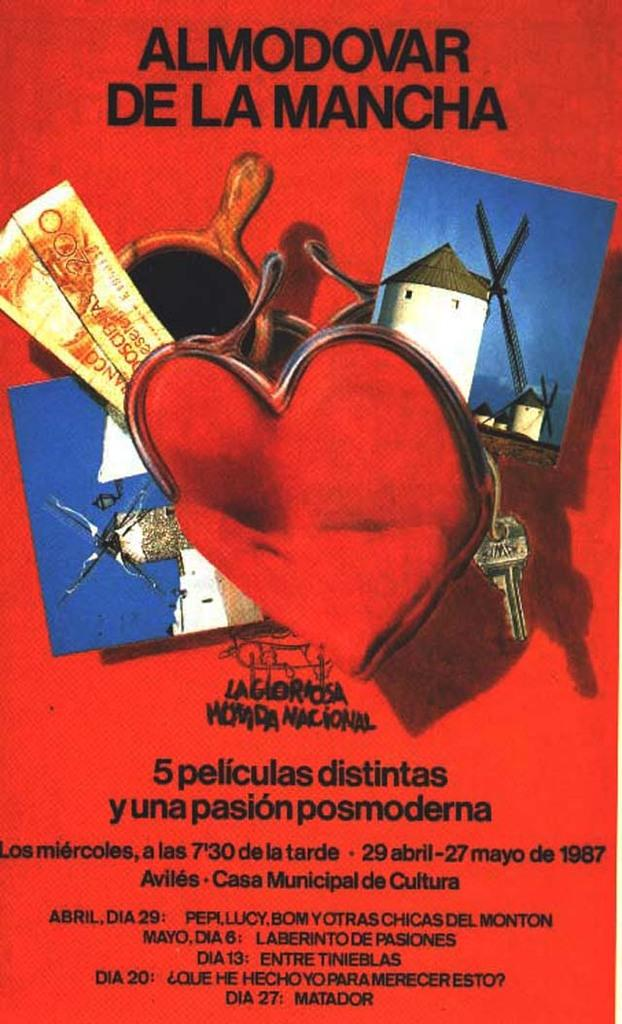<image>
Write a terse but informative summary of the picture. The poster cover of the Almodovar De La Mancha play 